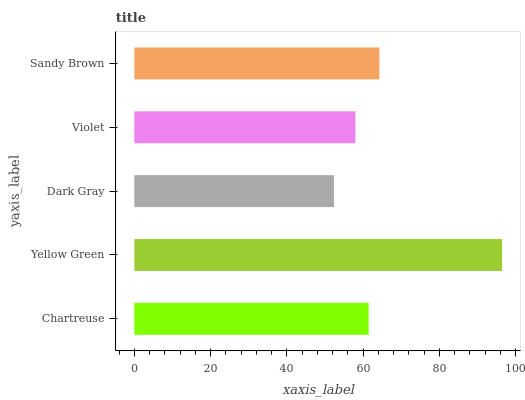Is Dark Gray the minimum?
Answer yes or no. Yes. Is Yellow Green the maximum?
Answer yes or no. Yes. Is Yellow Green the minimum?
Answer yes or no. No. Is Dark Gray the maximum?
Answer yes or no. No. Is Yellow Green greater than Dark Gray?
Answer yes or no. Yes. Is Dark Gray less than Yellow Green?
Answer yes or no. Yes. Is Dark Gray greater than Yellow Green?
Answer yes or no. No. Is Yellow Green less than Dark Gray?
Answer yes or no. No. Is Chartreuse the high median?
Answer yes or no. Yes. Is Chartreuse the low median?
Answer yes or no. Yes. Is Dark Gray the high median?
Answer yes or no. No. Is Yellow Green the low median?
Answer yes or no. No. 